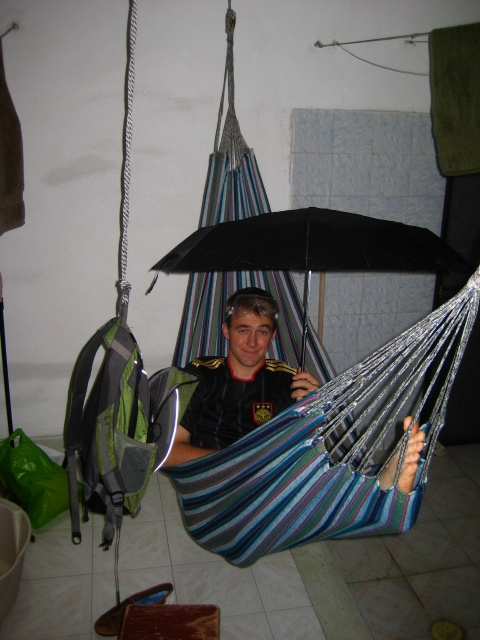Is there a bed frame nearby? No, there is no bed frame nearby. Is there a bed frame nearby? There is no bed frame nearby. It is also unknown if there is a bed frame nearby. 